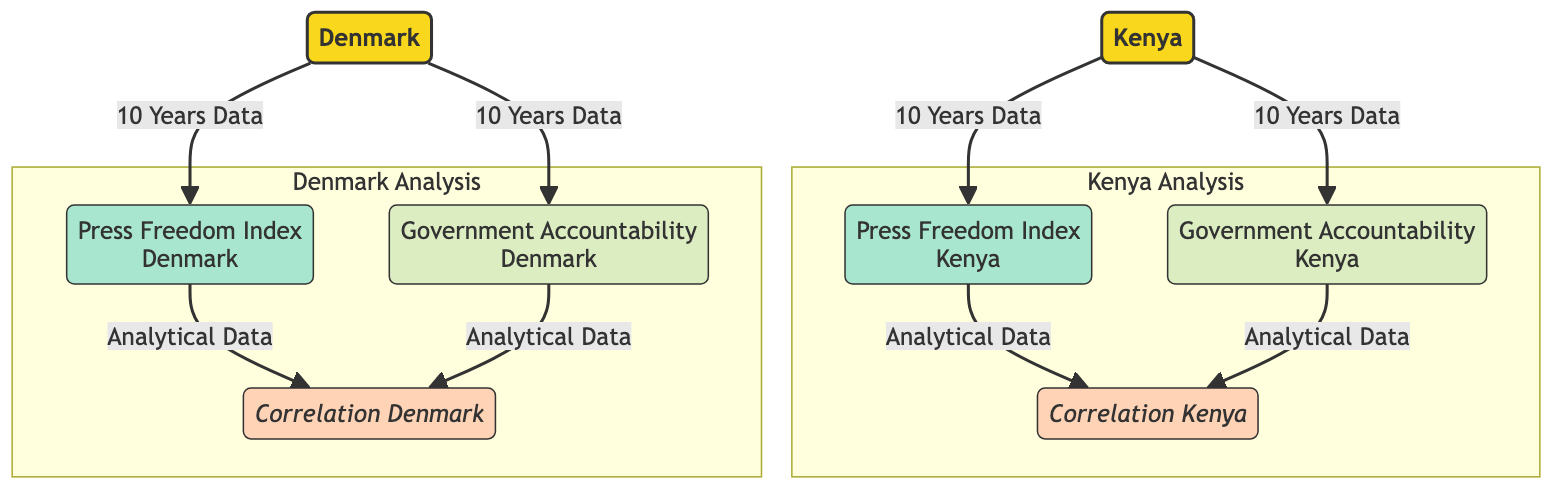What are the two countries represented in the diagram? The diagram explicitly labels the two countries as Kenya and Denmark. This information is found at the top of the flowchart.
Answer: Kenya and Denmark How many years of data are represented in the diagram? The diagram indicates that data for the last 10 years is included, as stated in the connecting arrows going from each country to their respective nodes.
Answer: 10 Years What does the abbreviation PFI stand for in the context of this diagram? The diagram provides a node labeled "Press Freedom Index" for both Kenya and Denmark. The abbreviation PFI is derived from the full term.
Answer: Press Freedom Index Which country shows a correlation node in the diagram? Both Kenya and Denmark have correlation nodes leading from their respective Press Freedom Index and Government Accountability nodes, making it clear that they both are elements in the analysis.
Answer: Kenya and Denmark What type of analysis does the correlation node in Kenya pertain to? The correlation node in Kenya is determined from two inputs: the Press Freedom Index and Government Accountability. Both nodes feed into this correlation node, indicating that it reflects the relationship between these two factors specifically in Kenya.
Answer: Correlation between Press Freedom Index and Government Accountability What is the visual representation type used in the diagram? The visual representation is a flowchart, as indicated by the flowchart section at the beginning of the coding structure, which governs the general layout of the nodes and flows.
Answer: Flowchart Which index is represented directly related to government accountability in Denmark? The diagram indicates a specific node labeled “Government Accountability” related to Denmark, which directly conveys the accountability aspect of the country in question.
Answer: Government Accountability What kind of data do the arrows leading to the correlation nodes represent? The arrows leading into the correlation nodes signify "Analytical Data" based on how the data flows from other nodes into them. This means these inputs are the basis for the correlation analysis.
Answer: Analytical Data Which class represents the countries in the diagram? The class specifically named “country” in the diagram defines the styling and visual representation of the nodes for both Kenya and Denmark within the flowchart.
Answer: country 